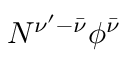Convert formula to latex. <formula><loc_0><loc_0><loc_500><loc_500>N ^ { \nu ^ { \prime } - \bar { \nu } } \phi ^ { \bar { \nu } }</formula> 